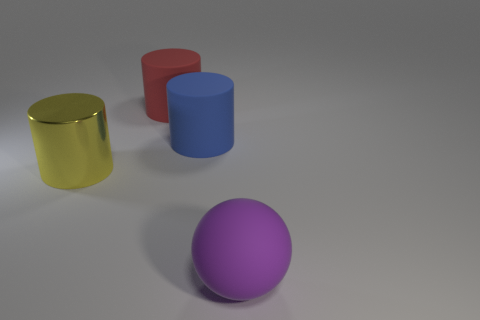Subtract all large blue cylinders. How many cylinders are left? 2 Add 1 tiny purple blocks. How many objects exist? 5 Subtract all balls. How many objects are left? 3 Subtract all green cylinders. Subtract all cyan spheres. How many cylinders are left? 3 Subtract 0 blue cubes. How many objects are left? 4 Subtract all small green metal objects. Subtract all yellow cylinders. How many objects are left? 3 Add 1 blue rubber cylinders. How many blue rubber cylinders are left? 2 Add 3 rubber objects. How many rubber objects exist? 6 